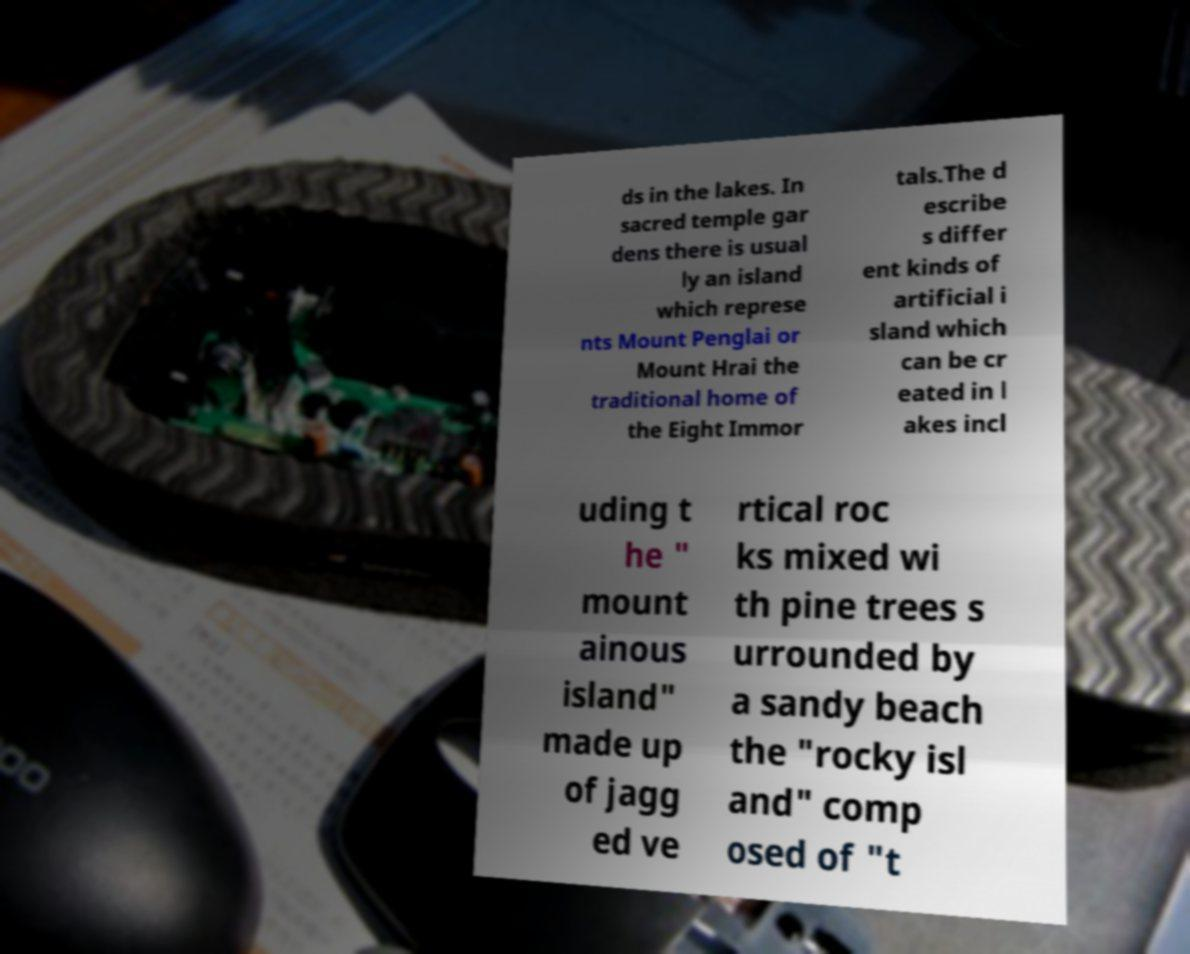Can you read and provide the text displayed in the image?This photo seems to have some interesting text. Can you extract and type it out for me? ds in the lakes. In sacred temple gar dens there is usual ly an island which represe nts Mount Penglai or Mount Hrai the traditional home of the Eight Immor tals.The d escribe s differ ent kinds of artificial i sland which can be cr eated in l akes incl uding t he " mount ainous island" made up of jagg ed ve rtical roc ks mixed wi th pine trees s urrounded by a sandy beach the "rocky isl and" comp osed of "t 